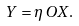<formula> <loc_0><loc_0><loc_500><loc_500>Y = \eta \, O X .</formula> 